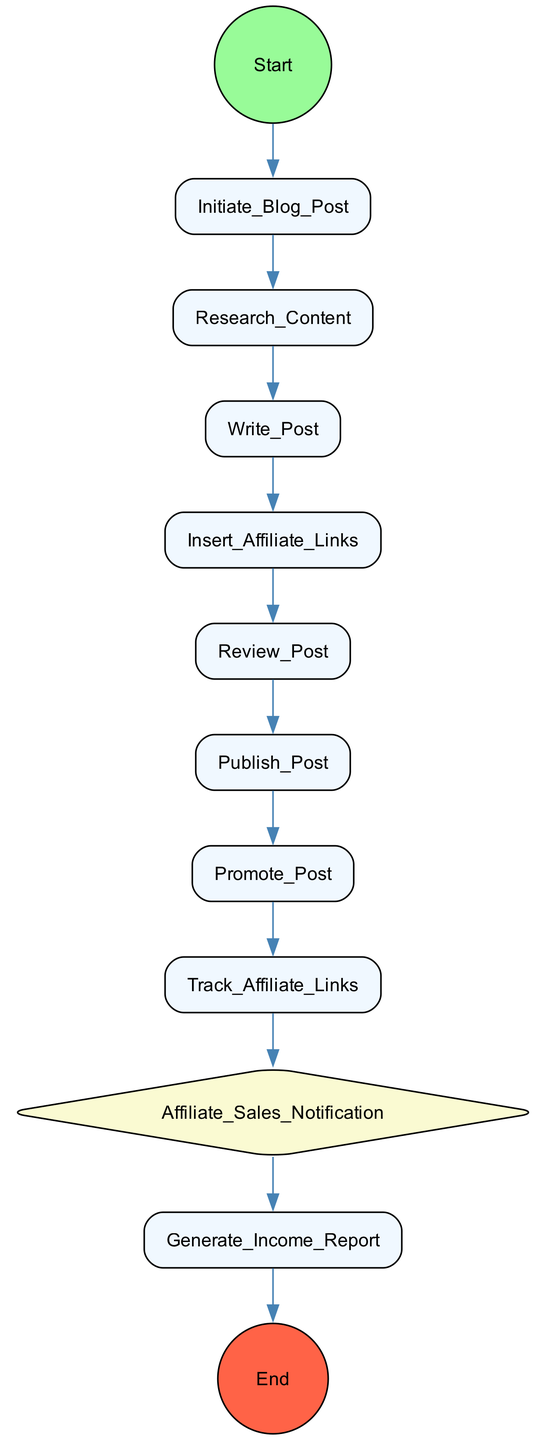What is the first action in the activity diagram? The first action is "Initiate_Blog_Post". This can be determined by looking at the order of actions in the diagram, where the first node represents the initial step.
Answer: Initiate_Blog_Post How many actions are shown in the diagram? There are a total of 8 actions represented in the diagram. This can be counted directly from the list of elements under the 'Action' type in the data.
Answer: 8 What is the last action before the end node? The last action before reaching the end node is "Promote_Post." This action connects directly to the end node based on the flow of the diagram.
Answer: Promote_Post Which node represents an event in the diagram? The node representing an event is "Affiliate_Sales_Notification." It is distinguishable by its diamond shape, which signifies an event in an activity diagram.
Answer: Affiliate_Sales_Notification What is the relationship between "Insert_Affiliate_Links" and "Review_Post"? "Insert_Affiliate_Links" comes before "Review_Post" in the sequence of actions. This shows that affiliate links must be inserted before the post can be reviewed.
Answer: Directly before After "Track_Affiliate_Links," what action follows? The action that follows "Track_Affiliate_Links" is "Affiliate_Sales_Notification." This indicates that tracking leads to notifications about sales.
Answer: Affiliate_Sales_Notification How do you generate an income report in the flow of actions? To generate an income report, one must perform the action "Generate_Income_Report" after receiving notifications from "Affiliate_Sales_Notification," implying a sequence in processing affiliate data.
Answer: Generate_Income_Report What are the final two actions in the activity diagram? The final two actions in the diagram are "Promote_Post" and the end node. "Promote_Post" leads directly to the completion of the flow, indicated by the flow connection to the end.
Answer: Promote_Post, End 